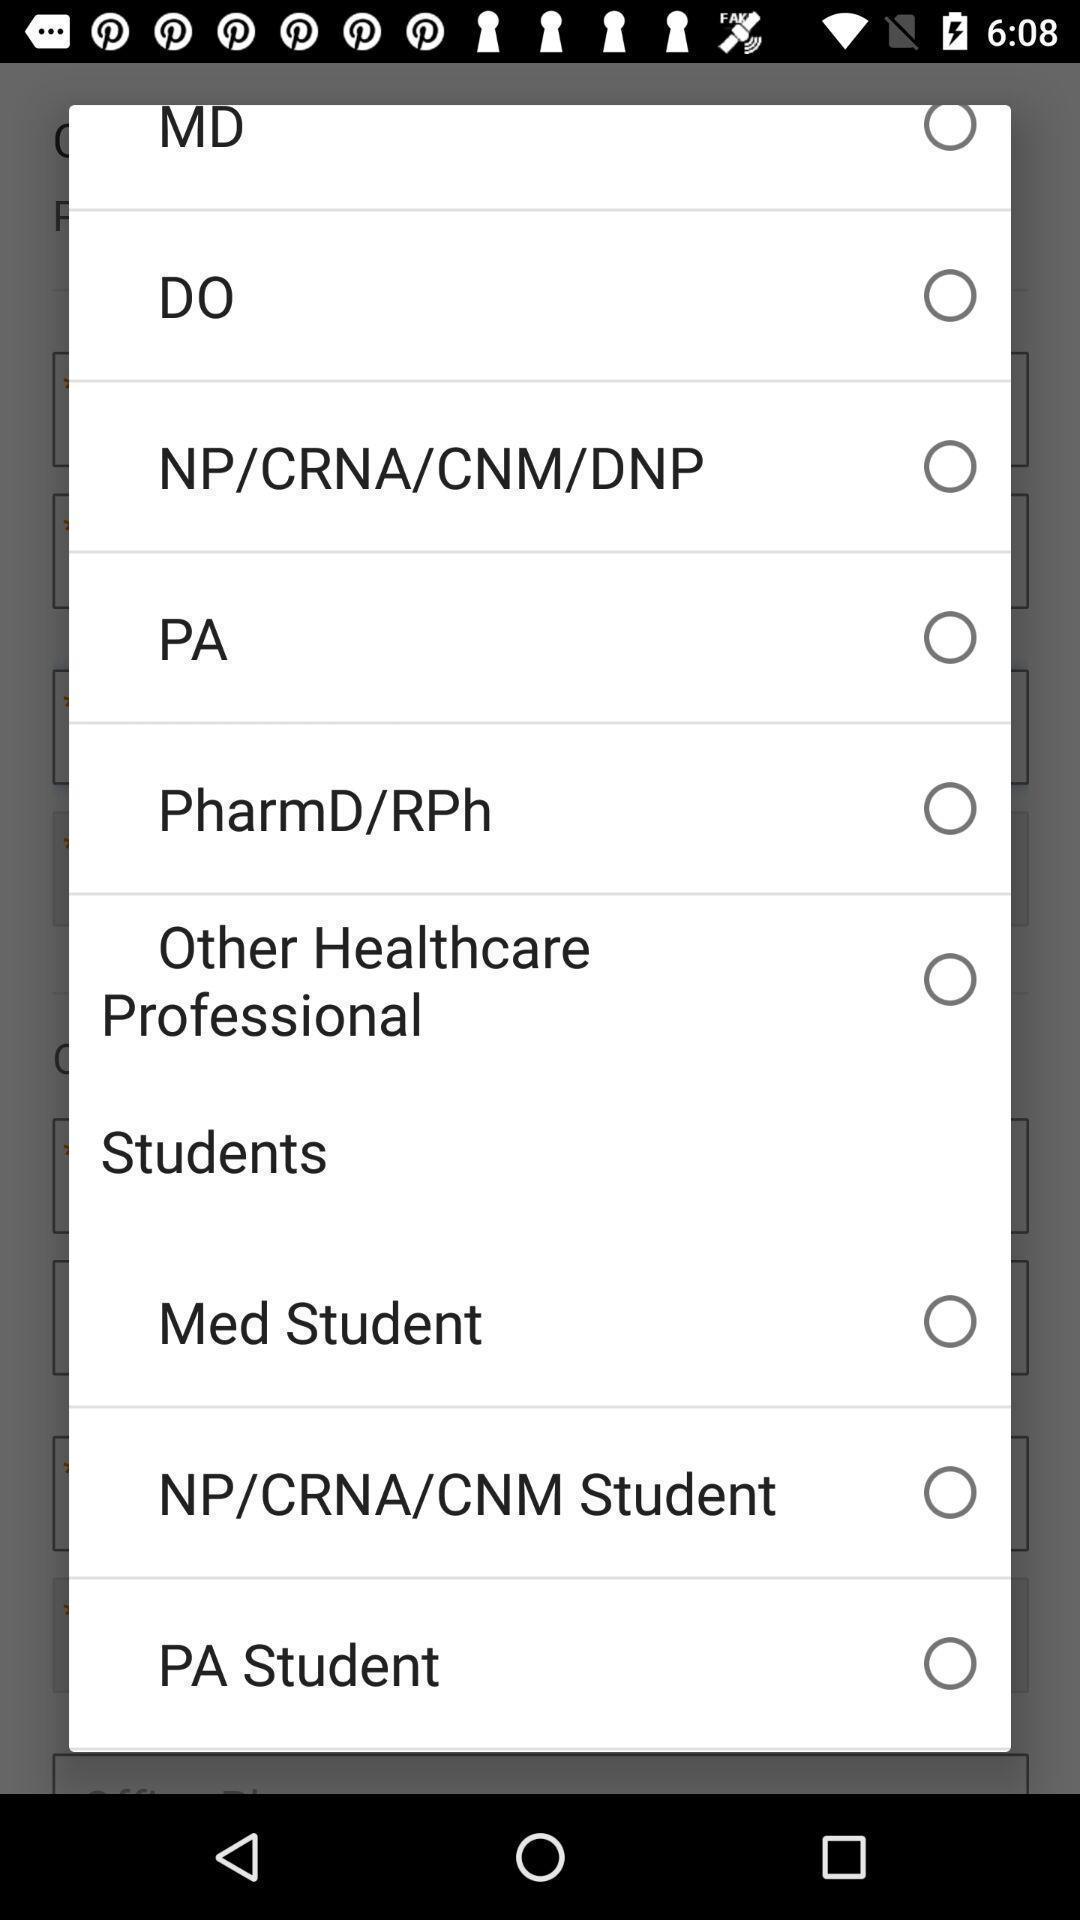Tell me about the visual elements in this screen capture. Popup showing different options for students. 